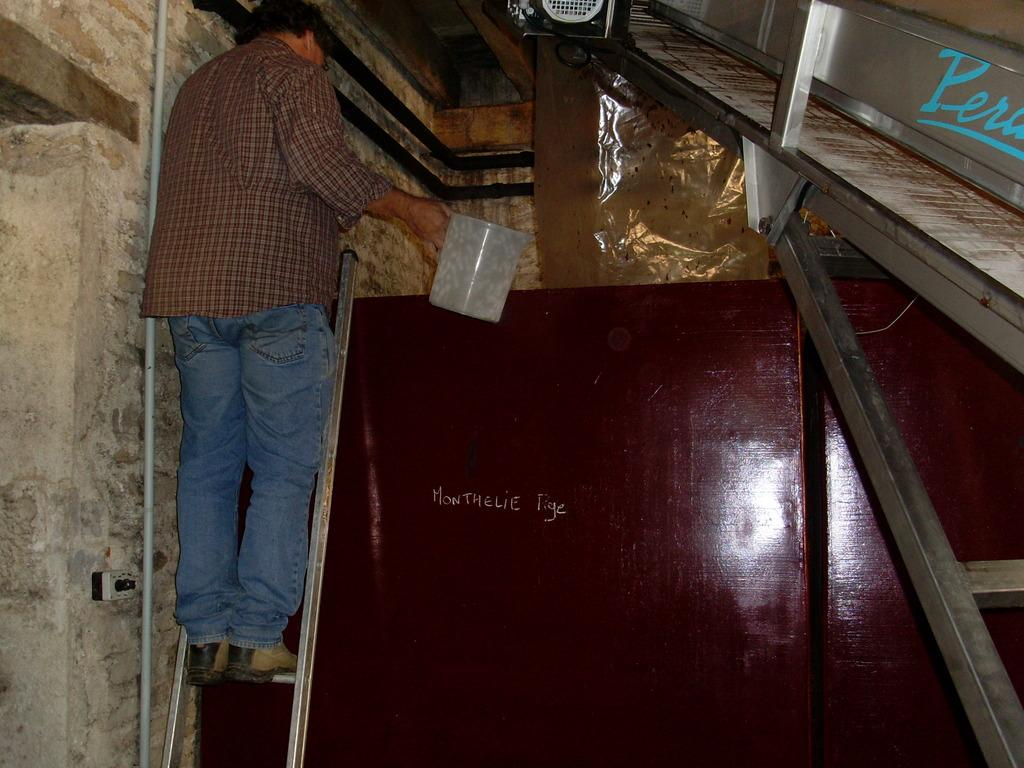What is the person in the image doing? The person is standing on a ladder in the image. What is the person holding while on the ladder? The person is holding a container. What can be seen behind the person on the ladder? There is a wall in the image. What other objects are present in the image? There is a pipe, rods, and a cover in the image. Can you see a whip being used by the person on the ladder in the image? No, there is no whip present in the image. Is there a kitty visible on the ladder with the person? No, there is no kitty present in the image. 